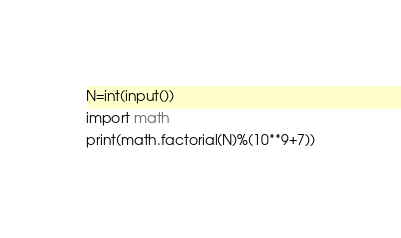<code> <loc_0><loc_0><loc_500><loc_500><_Python_>N=int(input())
import math
print(math.factorial(N)%(10**9+7))</code> 